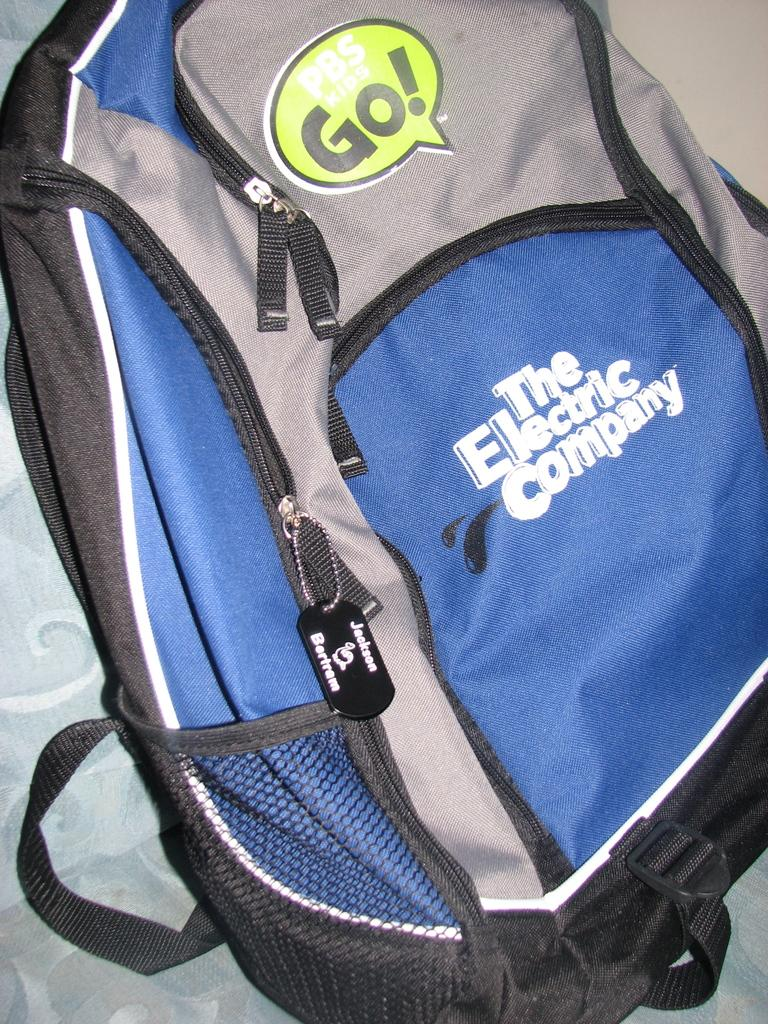<image>
Write a terse but informative summary of the picture. A gray, black and blue backpack with the words The Electric Company printed on it. 